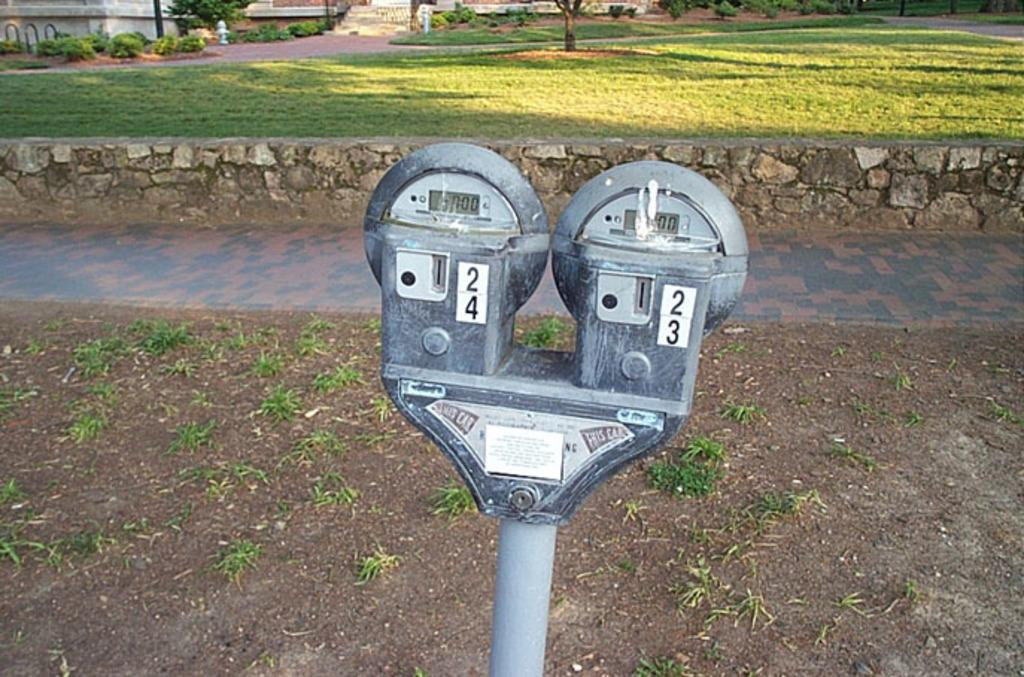<image>
Render a clear and concise summary of the photo. Parking meters number 23 and 24 are a worn-out pair located on a residential street. 